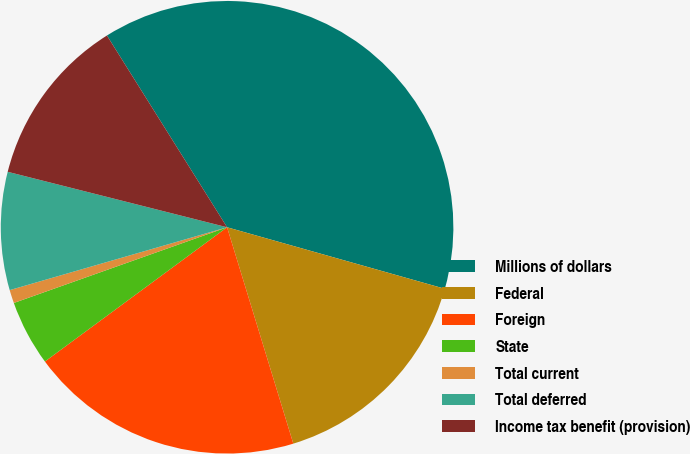Convert chart. <chart><loc_0><loc_0><loc_500><loc_500><pie_chart><fcel>Millions of dollars<fcel>Federal<fcel>Foreign<fcel>State<fcel>Total current<fcel>Total deferred<fcel>Income tax benefit (provision)<nl><fcel>38.29%<fcel>15.89%<fcel>19.62%<fcel>4.68%<fcel>0.95%<fcel>8.42%<fcel>12.15%<nl></chart> 